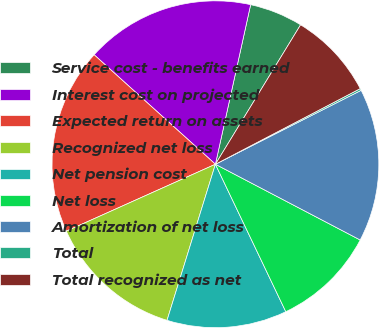<chart> <loc_0><loc_0><loc_500><loc_500><pie_chart><fcel>Service cost - benefits earned<fcel>Interest cost on projected<fcel>Expected return on assets<fcel>Recognized net loss<fcel>Net pension cost<fcel>Net loss<fcel>Amortization of net loss<fcel>Total<fcel>Total recognized as net<nl><fcel>5.27%<fcel>16.77%<fcel>18.4%<fcel>13.5%<fcel>11.87%<fcel>10.24%<fcel>15.14%<fcel>0.19%<fcel>8.61%<nl></chart> 